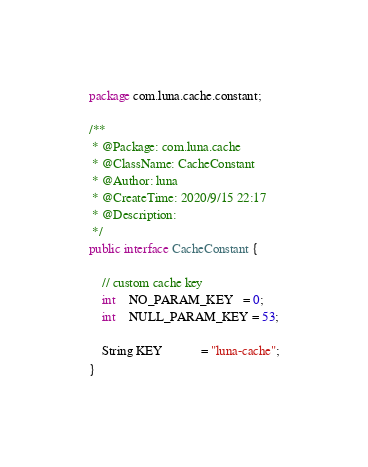Convert code to text. <code><loc_0><loc_0><loc_500><loc_500><_Java_>package com.luna.cache.constant;

/**
 * @Package: com.luna.cache
 * @ClassName: CacheConstant
 * @Author: luna
 * @CreateTime: 2020/9/15 22:17
 * @Description:
 */
public interface CacheConstant {

    // custom cache key
    int    NO_PARAM_KEY   = 0;
    int    NULL_PARAM_KEY = 53;

    String KEY            = "luna-cache";
}
</code> 